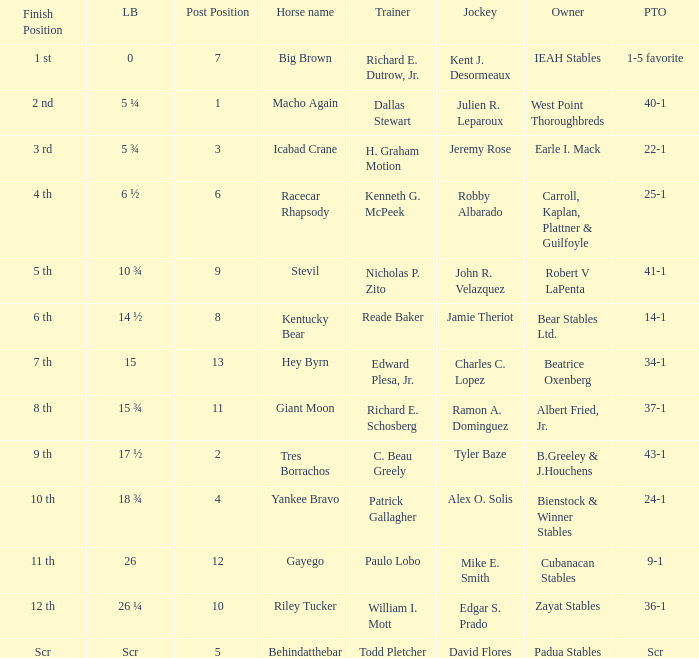What is the lengths behind of Jeremy Rose? 5 ¾. 